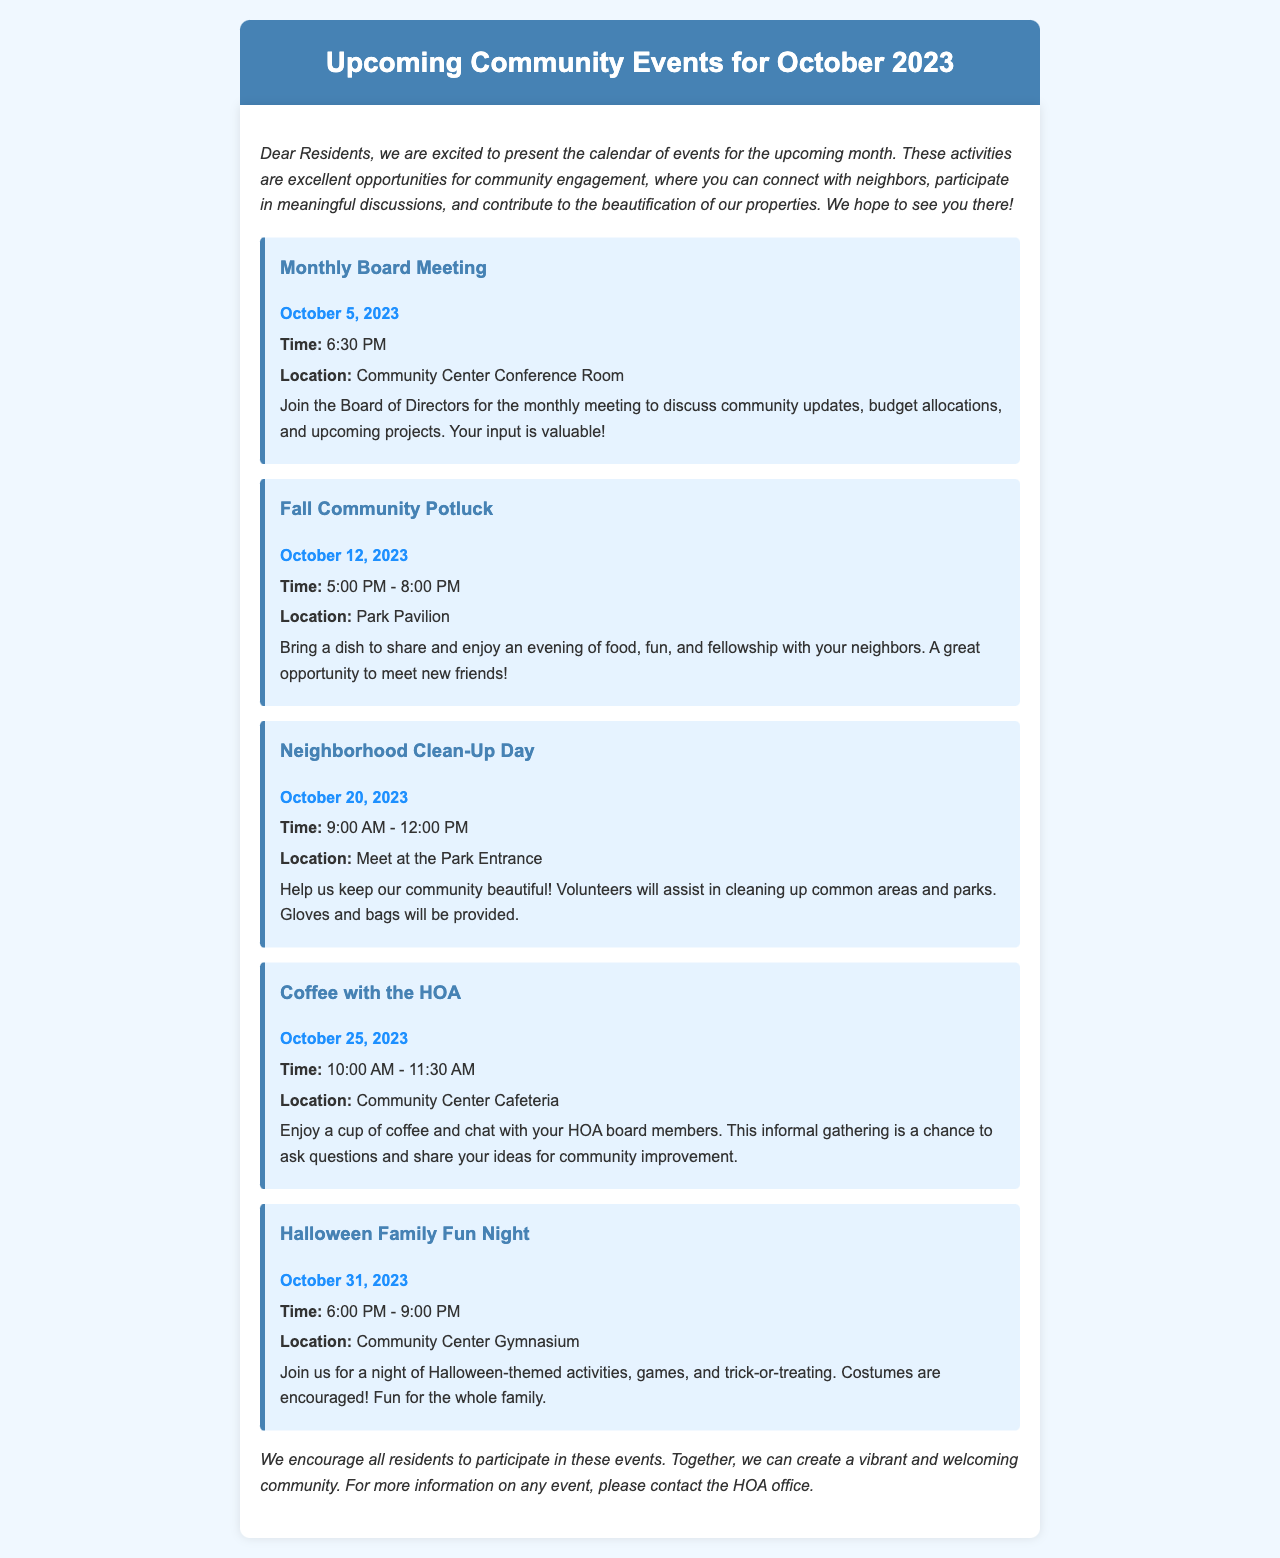What is the date of the Monthly Board Meeting? The date of the Monthly Board Meeting is explicitly stated in the document.
Answer: October 5, 2023 What time does the Fall Community Potluck start? The start time for the Fall Community Potluck is clearly mentioned in the event details.
Answer: 5:00 PM Where will the Neighborhood Clean-Up Day take place? The location for the Neighborhood Clean-Up Day is specified in the event description.
Answer: Meet at the Park Entrance How many events are listed for October 2023? The total number of events can be counted from the list presented in the newsletter.
Answer: 5 What is the purpose of the Coffee with the HOA event? The purpose is mentioned in the event description, indicating the intent for interaction with residents.
Answer: To chat with HOA board members Which event is scheduled for Halloween? The document identifies the event related to Halloween among others, specifying its name.
Answer: Halloween Family Fun Night What is provided for participants during the Neighborhood Clean-Up Day? The document mentions supplies given to volunteers, indicating the support provided for the event.
Answer: Gloves and bags What can residents expect at the Halloween Family Fun Night? The document describes activities included in the Halloween Family Fun Night, highlighting engagement.
Answer: Halloween-themed activities, games, and trick-or-treating 